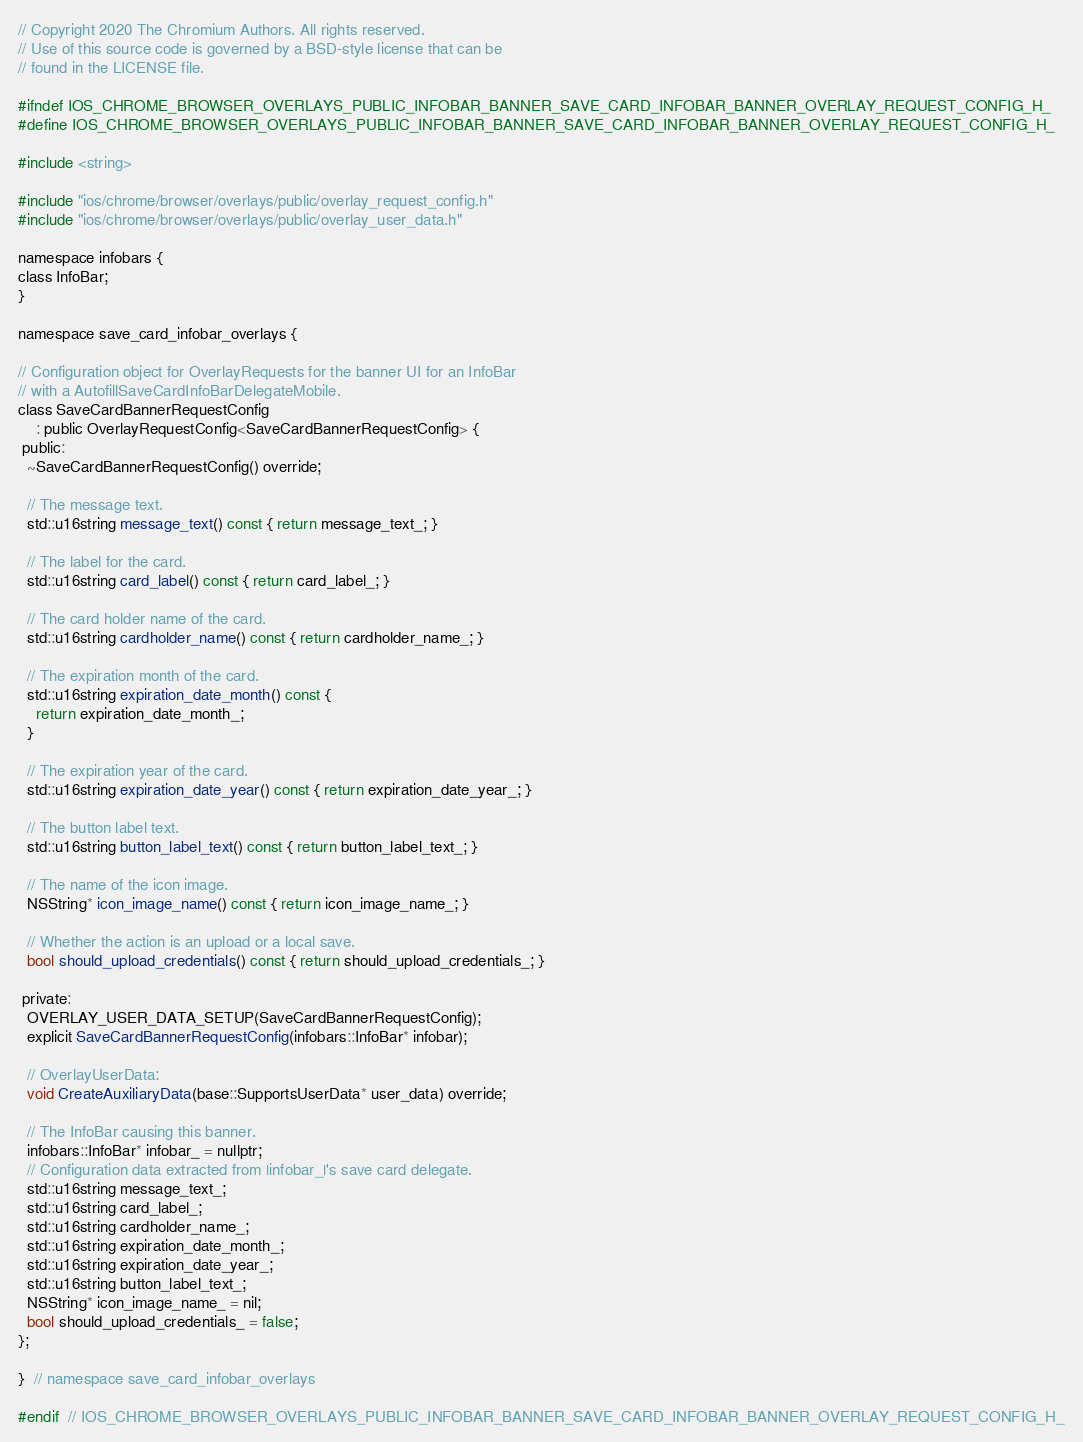<code> <loc_0><loc_0><loc_500><loc_500><_C_>// Copyright 2020 The Chromium Authors. All rights reserved.
// Use of this source code is governed by a BSD-style license that can be
// found in the LICENSE file.

#ifndef IOS_CHROME_BROWSER_OVERLAYS_PUBLIC_INFOBAR_BANNER_SAVE_CARD_INFOBAR_BANNER_OVERLAY_REQUEST_CONFIG_H_
#define IOS_CHROME_BROWSER_OVERLAYS_PUBLIC_INFOBAR_BANNER_SAVE_CARD_INFOBAR_BANNER_OVERLAY_REQUEST_CONFIG_H_

#include <string>

#include "ios/chrome/browser/overlays/public/overlay_request_config.h"
#include "ios/chrome/browser/overlays/public/overlay_user_data.h"

namespace infobars {
class InfoBar;
}

namespace save_card_infobar_overlays {

// Configuration object for OverlayRequests for the banner UI for an InfoBar
// with a AutofillSaveCardInfoBarDelegateMobile.
class SaveCardBannerRequestConfig
    : public OverlayRequestConfig<SaveCardBannerRequestConfig> {
 public:
  ~SaveCardBannerRequestConfig() override;

  // The message text.
  std::u16string message_text() const { return message_text_; }

  // The label for the card.
  std::u16string card_label() const { return card_label_; }

  // The card holder name of the card.
  std::u16string cardholder_name() const { return cardholder_name_; }

  // The expiration month of the card.
  std::u16string expiration_date_month() const {
    return expiration_date_month_;
  }

  // The expiration year of the card.
  std::u16string expiration_date_year() const { return expiration_date_year_; }

  // The button label text.
  std::u16string button_label_text() const { return button_label_text_; }

  // The name of the icon image.
  NSString* icon_image_name() const { return icon_image_name_; }

  // Whether the action is an upload or a local save.
  bool should_upload_credentials() const { return should_upload_credentials_; }

 private:
  OVERLAY_USER_DATA_SETUP(SaveCardBannerRequestConfig);
  explicit SaveCardBannerRequestConfig(infobars::InfoBar* infobar);

  // OverlayUserData:
  void CreateAuxiliaryData(base::SupportsUserData* user_data) override;

  // The InfoBar causing this banner.
  infobars::InfoBar* infobar_ = nullptr;
  // Configuration data extracted from |infobar_|'s save card delegate.
  std::u16string message_text_;
  std::u16string card_label_;
  std::u16string cardholder_name_;
  std::u16string expiration_date_month_;
  std::u16string expiration_date_year_;
  std::u16string button_label_text_;
  NSString* icon_image_name_ = nil;
  bool should_upload_credentials_ = false;
};

}  // namespace save_card_infobar_overlays

#endif  // IOS_CHROME_BROWSER_OVERLAYS_PUBLIC_INFOBAR_BANNER_SAVE_CARD_INFOBAR_BANNER_OVERLAY_REQUEST_CONFIG_H_
</code> 